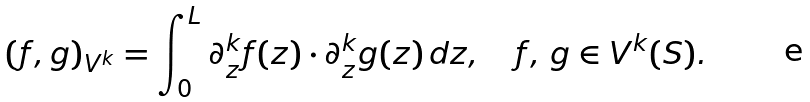Convert formula to latex. <formula><loc_0><loc_0><loc_500><loc_500>( f , g ) _ { V ^ { k } } = \int _ { 0 } ^ { L } \partial _ { z } ^ { k } f ( z ) \cdot \partial _ { z } ^ { k } g ( z ) \, d z , \quad f , \, g \in V ^ { k } ( S ) .</formula> 